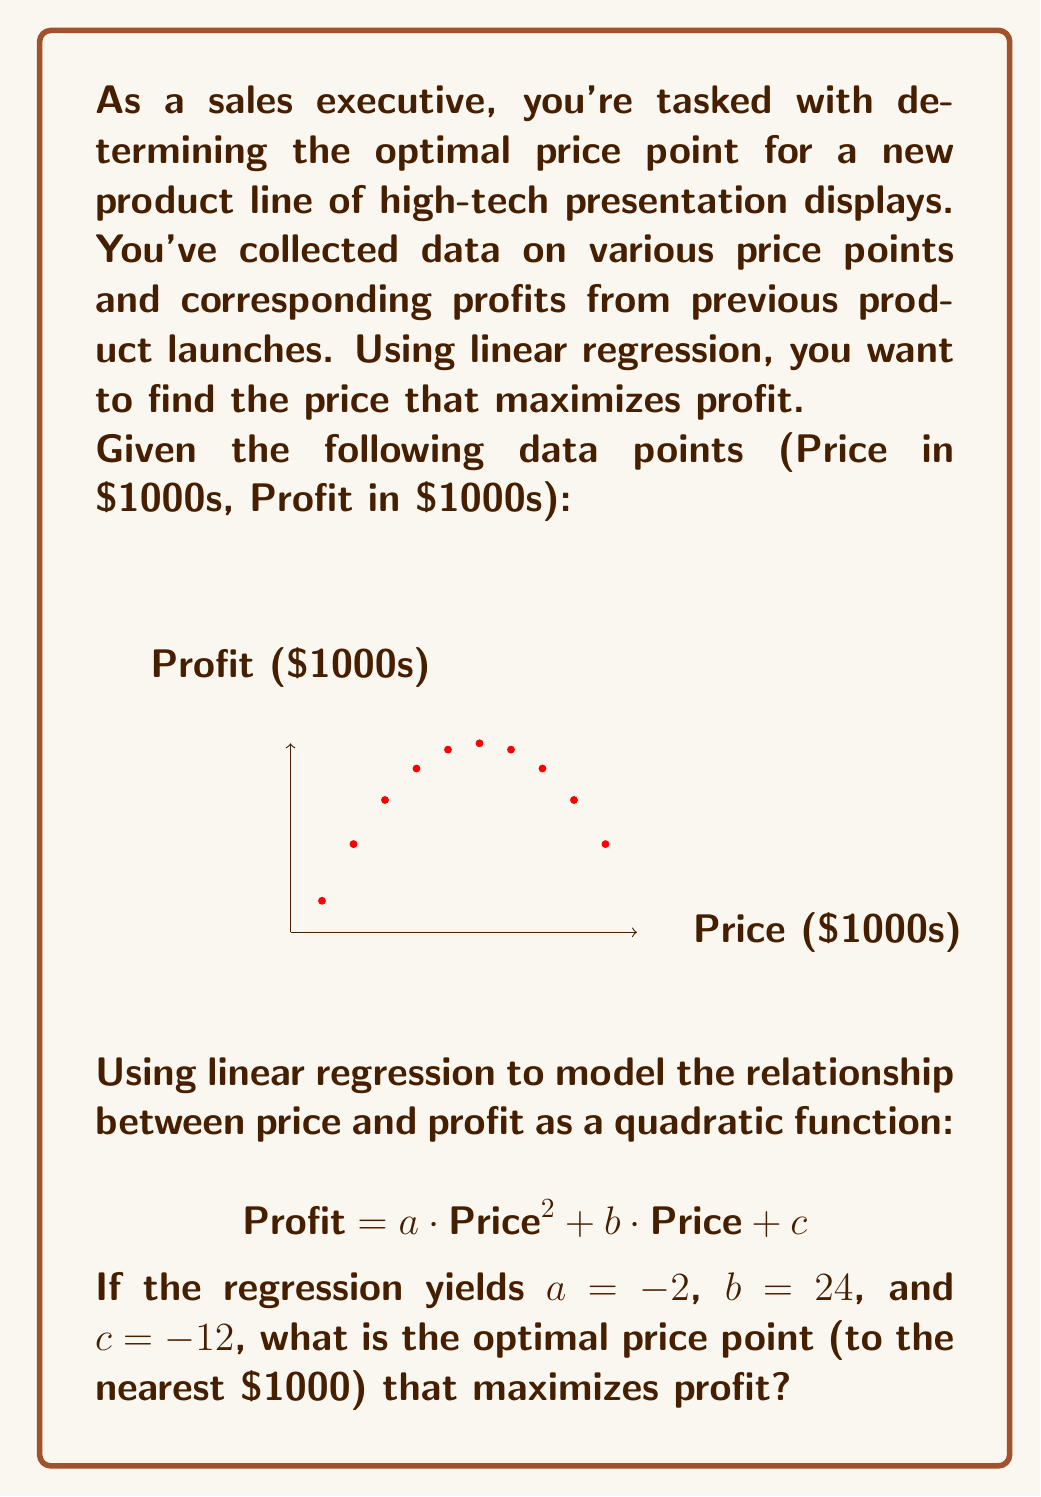Can you solve this math problem? To solve this problem, we'll follow these steps:

1) We have the quadratic function:
   $$ \text{Profit} = -2 \cdot \text{Price}^2 + 24 \cdot \text{Price} - 12 $$

2) To find the maximum of a quadratic function, we need to find the vertex. The x-coordinate of the vertex gives us the optimal price point.

3) For a quadratic function in the form $f(x) = ax^2 + bx + c$, the x-coordinate of the vertex is given by:
   $$ x = -\frac{b}{2a} $$

4) In our case, $a = -2$ and $b = 24$. Let's substitute these values:
   $$ \text{Optimal Price} = -\frac{24}{2(-2)} = -\frac{24}{-4} = 6 $$

5) Therefore, the optimal price point is $6,000.

6) To verify, we can calculate the profit at prices $5,000, $6,000, and $7,000:

   At $5,000: Profit = -2(5^2) + 24(5) - 12 = -50 + 120 - 12 = 58
   At $6,000: Profit = -2(6^2) + 24(6) - 12 = -72 + 144 - 12 = 60
   At $7,000: Profit = -2(7^2) + 24(7) - 12 = -98 + 168 - 12 = 58

   This confirms that $6,000 yields the highest profit.
Answer: $6,000 